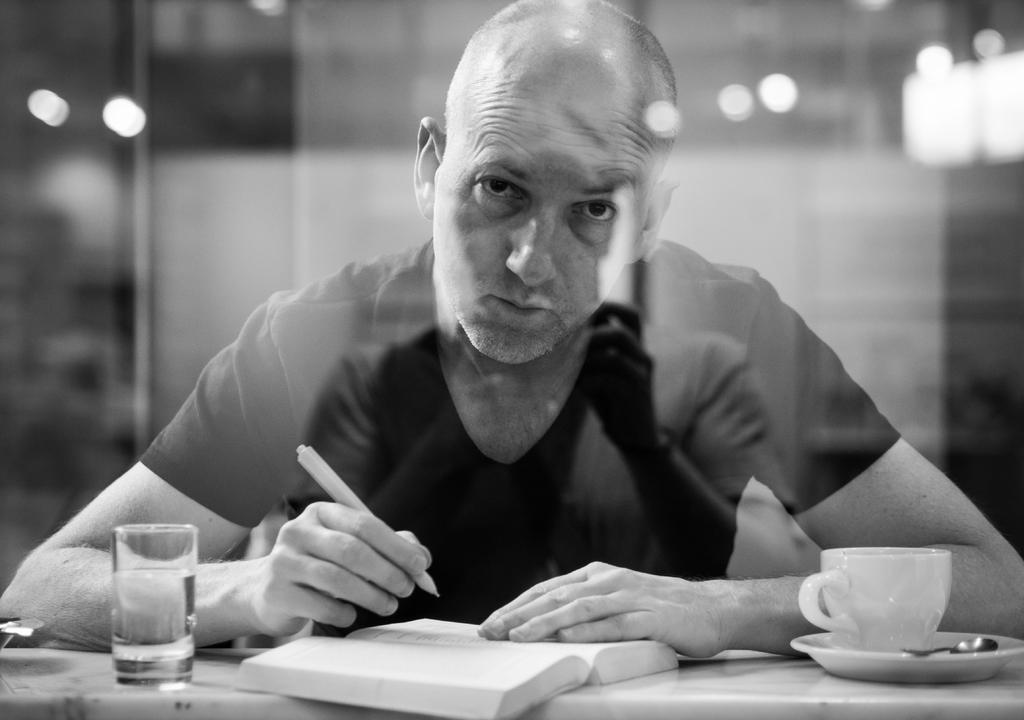What is the person in the image doing? The person is writing notes. What objects are on the table in the image? There is a glass, a cup, a spoon, and a plate on the table. Can you describe the person's activity in more detail? The person is likely taking notes or writing something down. What type of connection is the person making with the needle in the image? There is no needle present in the image. How many eggs are visible on the table in the image? There are no eggs visible on the table in the image. 